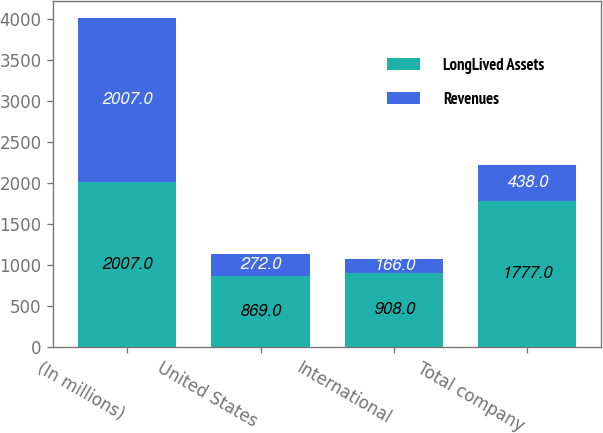Convert chart to OTSL. <chart><loc_0><loc_0><loc_500><loc_500><stacked_bar_chart><ecel><fcel>(In millions)<fcel>United States<fcel>International<fcel>Total company<nl><fcel>LongLived Assets<fcel>2007<fcel>869<fcel>908<fcel>1777<nl><fcel>Revenues<fcel>2007<fcel>272<fcel>166<fcel>438<nl></chart> 